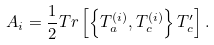Convert formula to latex. <formula><loc_0><loc_0><loc_500><loc_500>A _ { i } = \frac { 1 } { 2 } T r \left [ \left \{ T ^ { ( i ) } _ { a } , T ^ { ( i ) } _ { c } \right \} T ^ { \prime } _ { c } \right ] .</formula> 